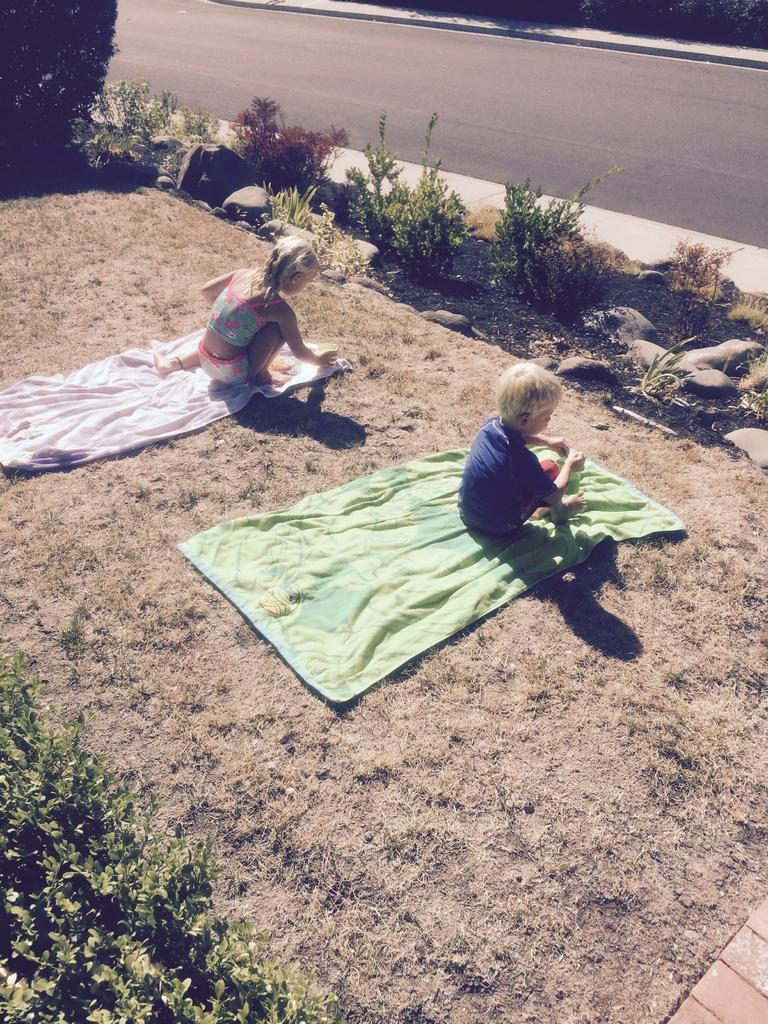What is the main feature of the image? There is a road in the image. What else can be seen in the image besides the road? There are plants and two children in the image. What might the children be using for a picnic or playtime? There is a blanket on the ground in the image. What type of box is being used by the children to play with in the image? There is no box present in the image; the children are not playing with any box. 